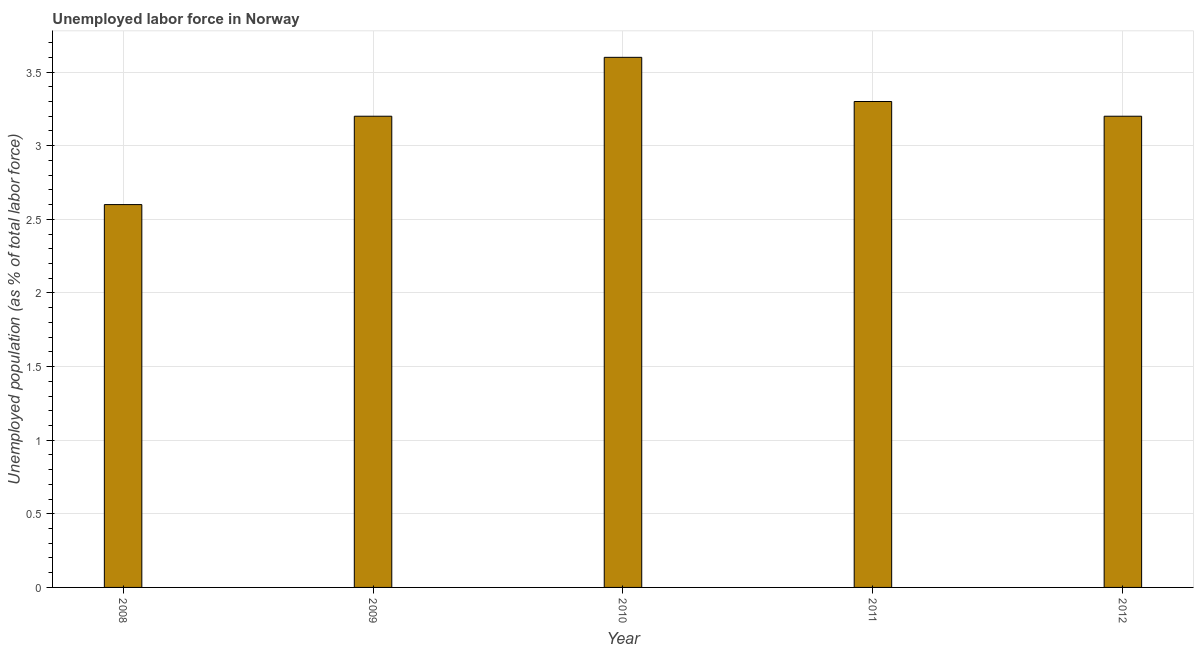Does the graph contain grids?
Provide a short and direct response. Yes. What is the title of the graph?
Offer a terse response. Unemployed labor force in Norway. What is the label or title of the Y-axis?
Ensure brevity in your answer.  Unemployed population (as % of total labor force). What is the total unemployed population in 2011?
Keep it short and to the point. 3.3. Across all years, what is the maximum total unemployed population?
Make the answer very short. 3.6. Across all years, what is the minimum total unemployed population?
Offer a terse response. 2.6. In which year was the total unemployed population maximum?
Offer a very short reply. 2010. What is the sum of the total unemployed population?
Provide a short and direct response. 15.9. What is the average total unemployed population per year?
Give a very brief answer. 3.18. What is the median total unemployed population?
Offer a very short reply. 3.2. In how many years, is the total unemployed population greater than 0.6 %?
Offer a terse response. 5. Do a majority of the years between 2010 and 2012 (inclusive) have total unemployed population greater than 2.4 %?
Give a very brief answer. Yes. Is the difference between the total unemployed population in 2009 and 2012 greater than the difference between any two years?
Your response must be concise. No. Is the sum of the total unemployed population in 2008 and 2009 greater than the maximum total unemployed population across all years?
Give a very brief answer. Yes. Are all the bars in the graph horizontal?
Ensure brevity in your answer.  No. What is the Unemployed population (as % of total labor force) of 2008?
Your answer should be very brief. 2.6. What is the Unemployed population (as % of total labor force) of 2009?
Your answer should be very brief. 3.2. What is the Unemployed population (as % of total labor force) of 2010?
Offer a very short reply. 3.6. What is the Unemployed population (as % of total labor force) in 2011?
Provide a succinct answer. 3.3. What is the Unemployed population (as % of total labor force) in 2012?
Make the answer very short. 3.2. What is the difference between the Unemployed population (as % of total labor force) in 2008 and 2009?
Provide a succinct answer. -0.6. What is the difference between the Unemployed population (as % of total labor force) in 2009 and 2011?
Your response must be concise. -0.1. What is the difference between the Unemployed population (as % of total labor force) in 2009 and 2012?
Provide a short and direct response. 0. What is the difference between the Unemployed population (as % of total labor force) in 2010 and 2011?
Make the answer very short. 0.3. What is the difference between the Unemployed population (as % of total labor force) in 2010 and 2012?
Provide a short and direct response. 0.4. What is the ratio of the Unemployed population (as % of total labor force) in 2008 to that in 2009?
Give a very brief answer. 0.81. What is the ratio of the Unemployed population (as % of total labor force) in 2008 to that in 2010?
Give a very brief answer. 0.72. What is the ratio of the Unemployed population (as % of total labor force) in 2008 to that in 2011?
Offer a very short reply. 0.79. What is the ratio of the Unemployed population (as % of total labor force) in 2008 to that in 2012?
Make the answer very short. 0.81. What is the ratio of the Unemployed population (as % of total labor force) in 2009 to that in 2010?
Your response must be concise. 0.89. What is the ratio of the Unemployed population (as % of total labor force) in 2009 to that in 2011?
Your answer should be compact. 0.97. What is the ratio of the Unemployed population (as % of total labor force) in 2009 to that in 2012?
Ensure brevity in your answer.  1. What is the ratio of the Unemployed population (as % of total labor force) in 2010 to that in 2011?
Keep it short and to the point. 1.09. What is the ratio of the Unemployed population (as % of total labor force) in 2010 to that in 2012?
Your response must be concise. 1.12. What is the ratio of the Unemployed population (as % of total labor force) in 2011 to that in 2012?
Keep it short and to the point. 1.03. 